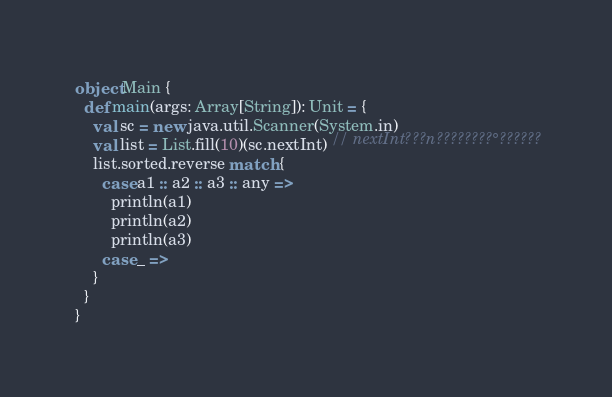Convert code to text. <code><loc_0><loc_0><loc_500><loc_500><_Scala_>object Main {
  def main(args: Array[String]): Unit = {
    val sc = new java.util.Scanner(System.in)
    val list = List.fill(10)(sc.nextInt) // nextInt???n????????°??????
    list.sorted.reverse match {
      case a1 :: a2 :: a3 :: any =>
        println(a1)
        println(a2)
        println(a3)
      case _ =>
    }
  }
}</code> 